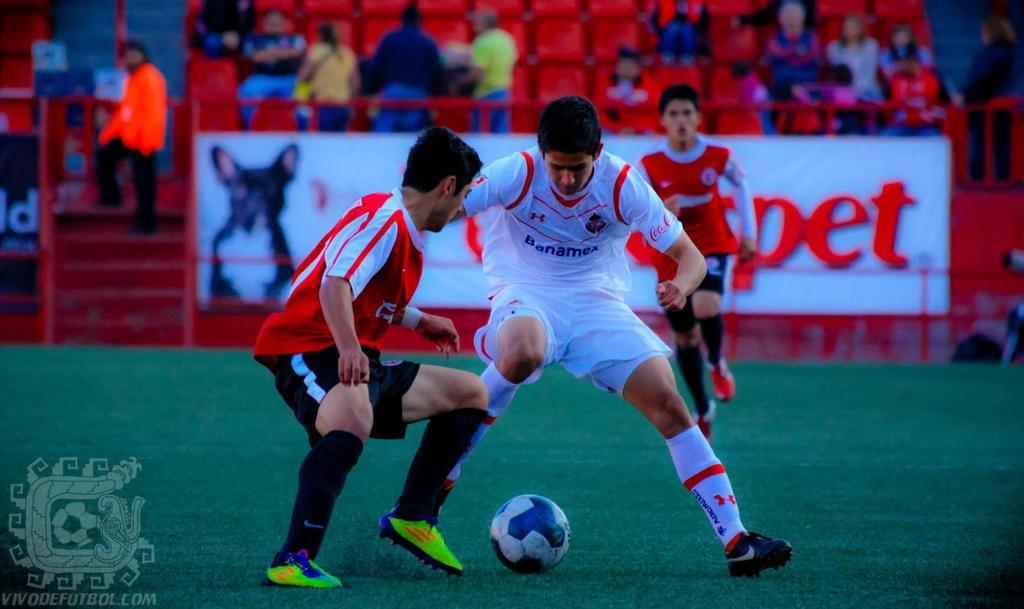<image>
Present a compact description of the photo's key features. Soccer player in a white Banamex jersey is battling for the ball against a player in red and black. 